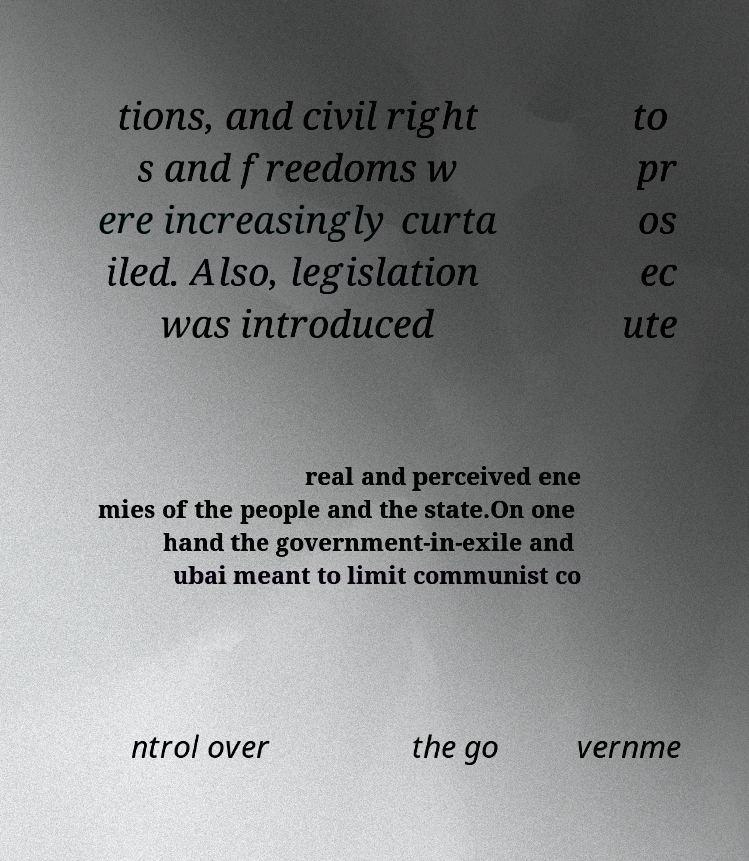Could you assist in decoding the text presented in this image and type it out clearly? tions, and civil right s and freedoms w ere increasingly curta iled. Also, legislation was introduced to pr os ec ute real and perceived ene mies of the people and the state.On one hand the government-in-exile and ubai meant to limit communist co ntrol over the go vernme 